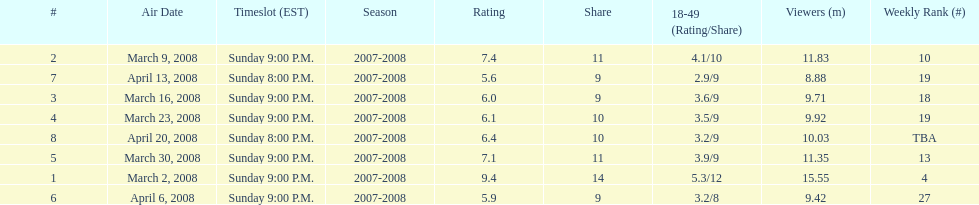Parse the table in full. {'header': ['#', 'Air Date', 'Timeslot (EST)', 'Season', 'Rating', 'Share', '18-49 (Rating/Share)', 'Viewers (m)', 'Weekly Rank (#)'], 'rows': [['2', 'March 9, 2008', 'Sunday 9:00 P.M.', '2007-2008', '7.4', '11', '4.1/10', '11.83', '10'], ['7', 'April 13, 2008', 'Sunday 8:00 P.M.', '2007-2008', '5.6', '9', '2.9/9', '8.88', '19'], ['3', 'March 16, 2008', 'Sunday 9:00 P.M.', '2007-2008', '6.0', '9', '3.6/9', '9.71', '18'], ['4', 'March 23, 2008', 'Sunday 9:00 P.M.', '2007-2008', '6.1', '10', '3.5/9', '9.92', '19'], ['8', 'April 20, 2008', 'Sunday 8:00 P.M.', '2007-2008', '6.4', '10', '3.2/9', '10.03', 'TBA'], ['5', 'March 30, 2008', 'Sunday 9:00 P.M.', '2007-2008', '7.1', '11', '3.9/9', '11.35', '13'], ['1', 'March 2, 2008', 'Sunday 9:00 P.M.', '2007-2008', '9.4', '14', '5.3/12', '15.55', '4'], ['6', 'April 6, 2008', 'Sunday 9:00 P.M.', '2007-2008', '5.9', '9', '3.2/8', '9.42', '27']]} Which air date had the least viewers? April 13, 2008. 